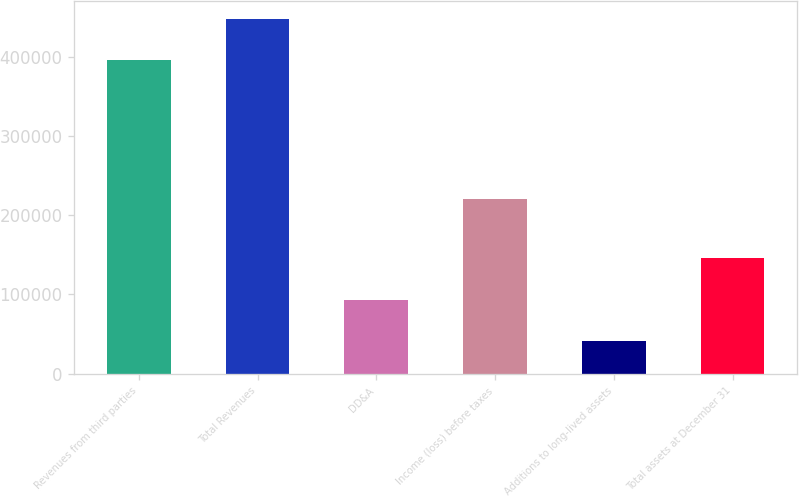<chart> <loc_0><loc_0><loc_500><loc_500><bar_chart><fcel>Revenues from third parties<fcel>Total Revenues<fcel>DD&A<fcel>Income (loss) before taxes<fcel>Additions to long-lived assets<fcel>Total assets at December 31<nl><fcel>395353<fcel>447470<fcel>93086.1<fcel>220779<fcel>40969<fcel>146311<nl></chart> 